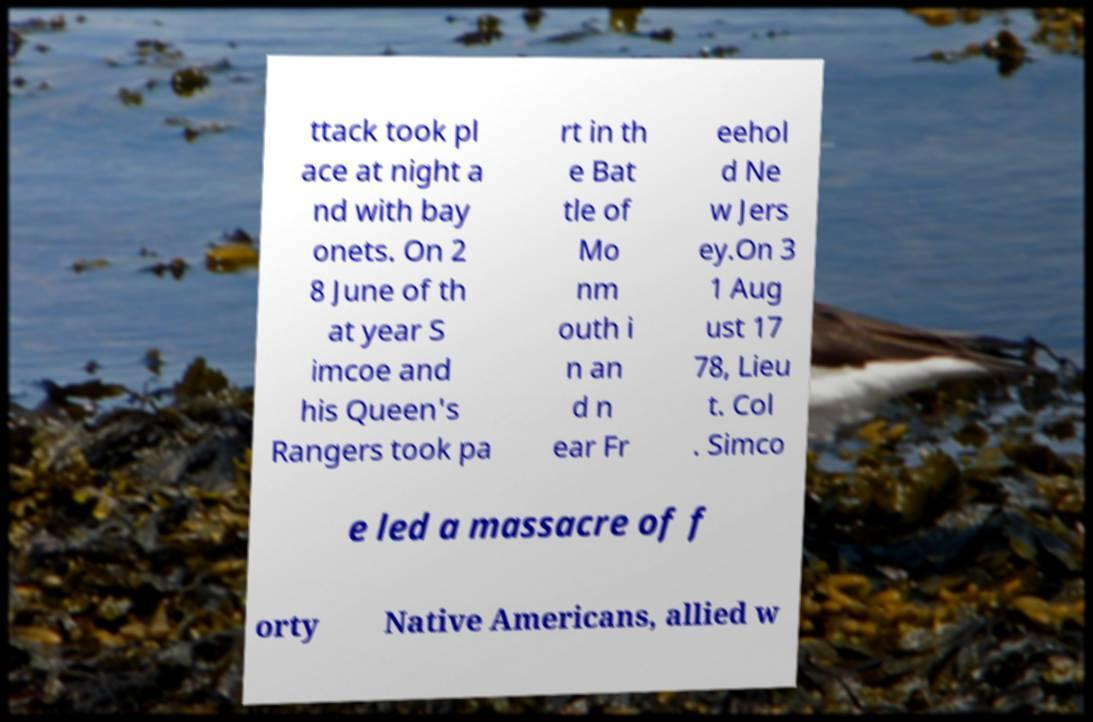What messages or text are displayed in this image? I need them in a readable, typed format. ttack took pl ace at night a nd with bay onets. On 2 8 June of th at year S imcoe and his Queen's Rangers took pa rt in th e Bat tle of Mo nm outh i n an d n ear Fr eehol d Ne w Jers ey.On 3 1 Aug ust 17 78, Lieu t. Col . Simco e led a massacre of f orty Native Americans, allied w 